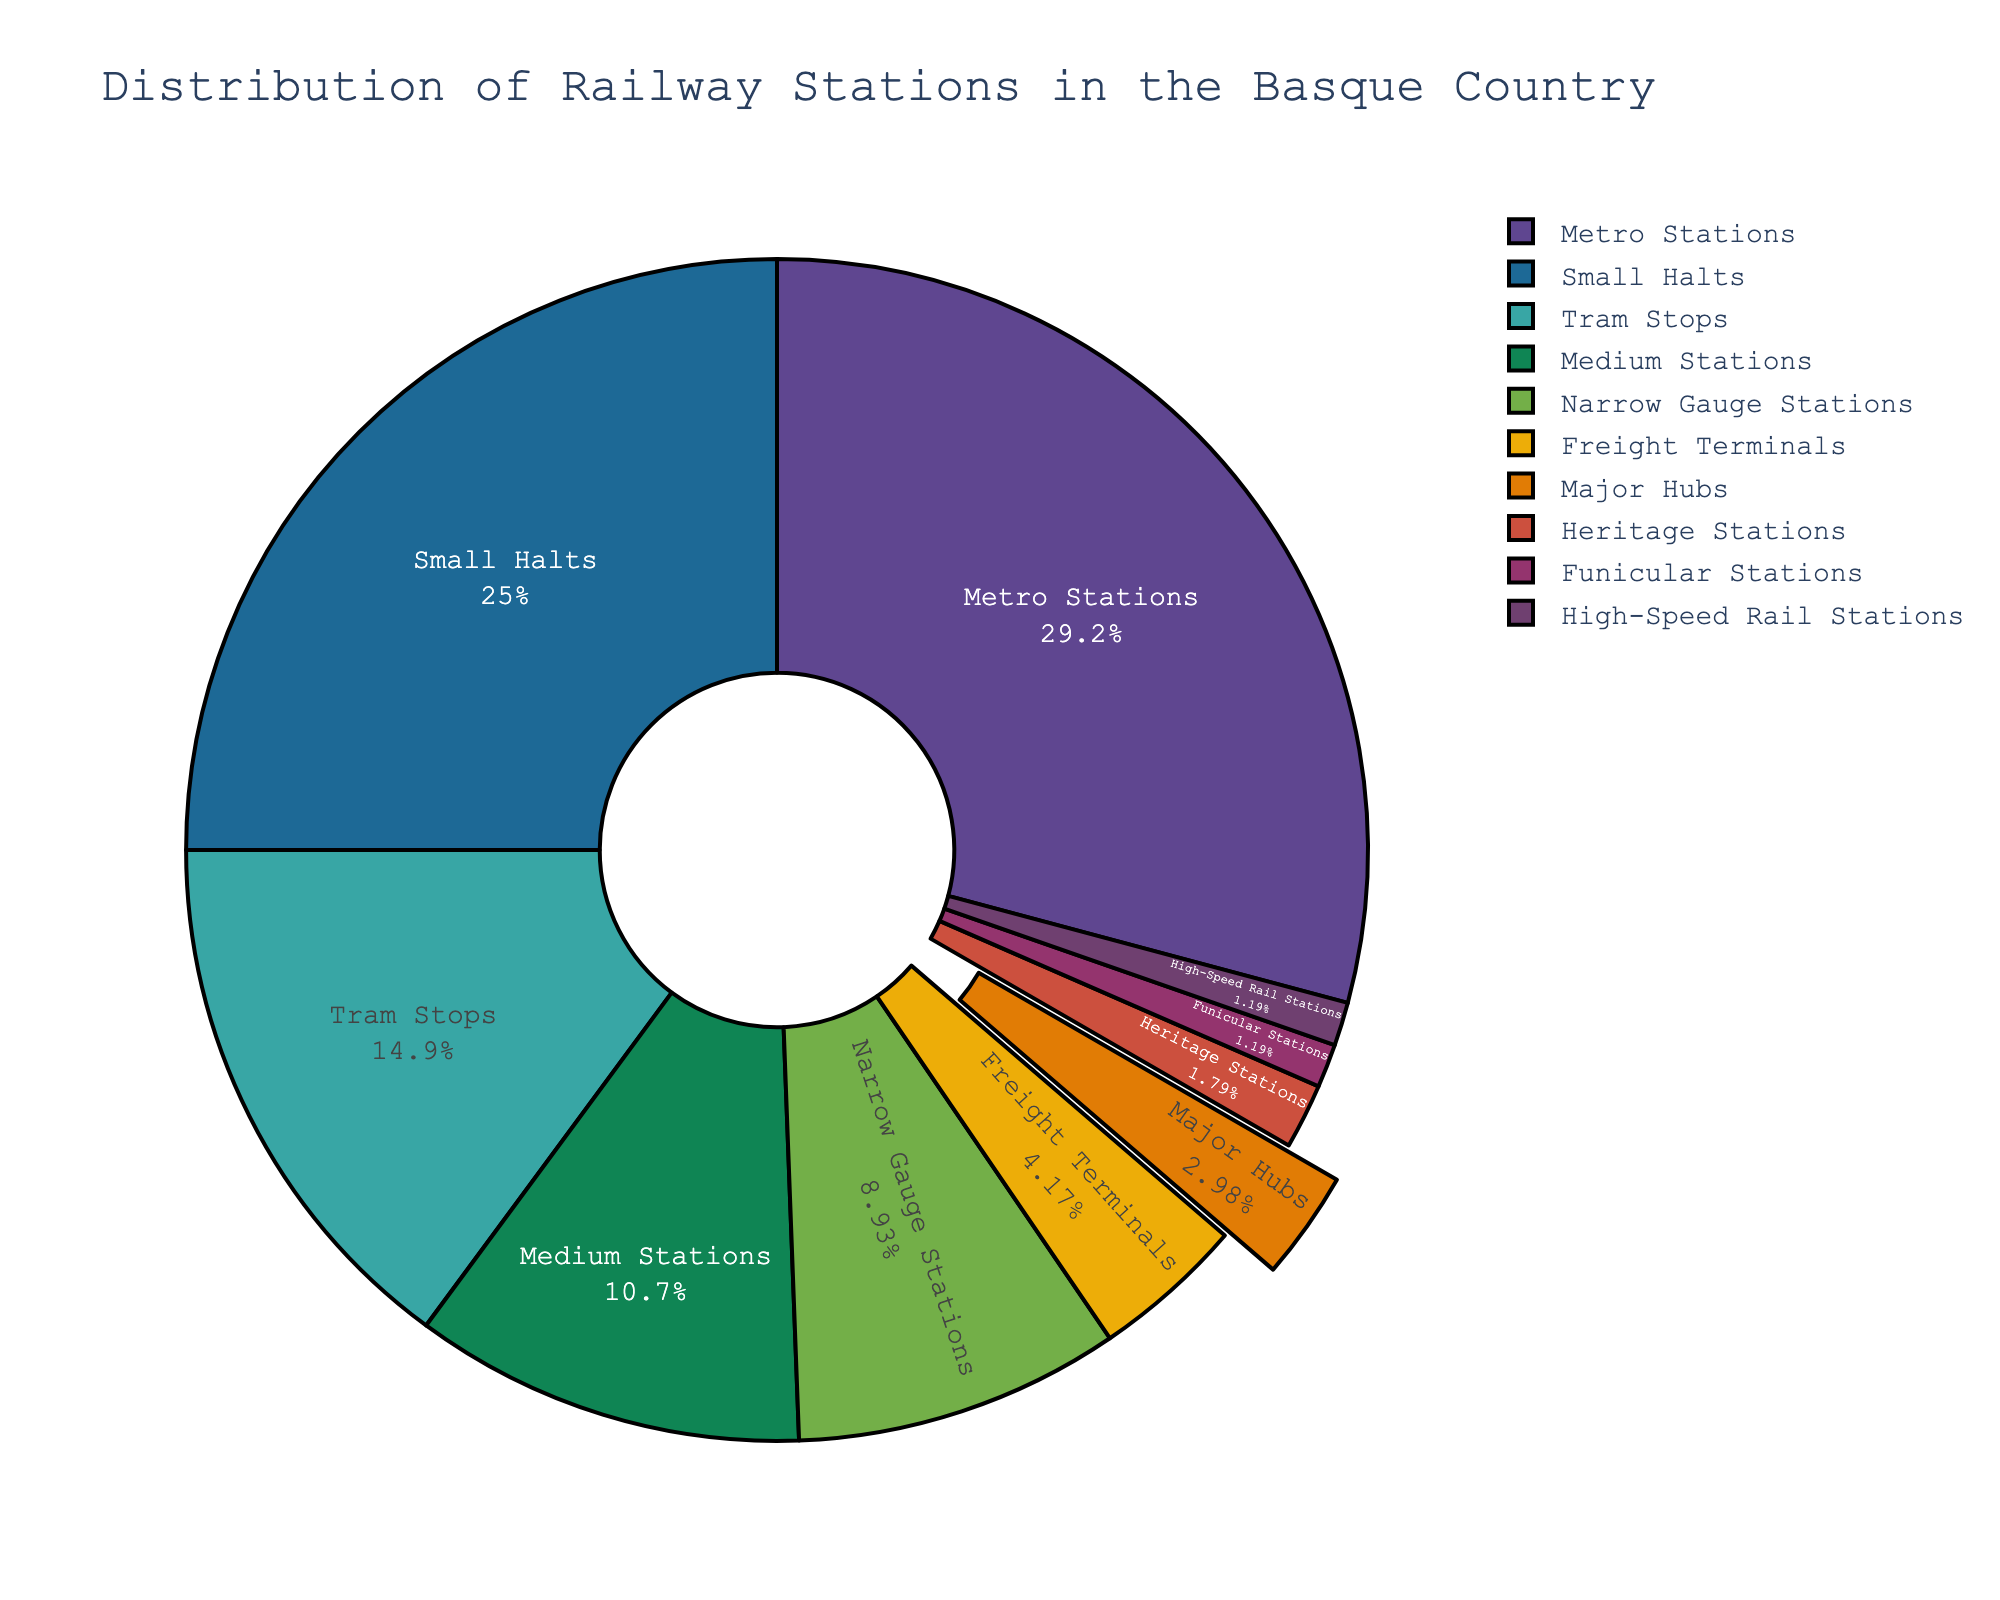Which type of station has the highest percentage in the distribution? By looking at the pie chart, we can see that metro stations occupy the largest portion of the pie chart, indicating they have the highest percentage.
Answer: Metro Stations How many more small halts are there than major hubs? From the data, there are 42 small halts and 5 major hubs. Subtract the number of major hubs from the number of small halts, which is 42 - 5.
Answer: 37 What is the combined percentage of high-speed rail stations and funicular stations? Identify the segments for high-speed rail and funicular stations and add their percentages together from the pie chart. Each has small, equal segments indicating the sizes are very similar.
Answer: ~4% (assuming each approximately 2%) Compare the number of medium stations and narrow gauge stations. Which is greater, and by how much? The pie chart shows there are 18 medium stations and 15 narrow gauge stations. Subtract the number of narrow gauge stations from medium stations to find the difference.
Answer: Medium stations by 3 What is the percentage of metro stations relative to the total number of stations? First, sum the total number of stations from all categories, which is 168. Divide the number of metro stations (49) by the total to find the percentage: (49 / 168) * 100.
Answer: ~29.2% Which types of stations together make up more than half of the total stations? Sum the percentages of the top types from the pie chart until you exceed 50%. Metro stations, small halts, and tram stops together exceed half the total stations.
Answer: Metro Stations, Small Halts, Tram Stops What fraction of the total stations are major hubs? Divide the number of major hubs (5) by the total number of stations (168) to form a fraction.
Answer: 5/168 or simplified approximately 1/34 If you combine freight terminals and heritage stations, what is their combined share among the total number of stations? Add the number of freight terminals and heritage stations: 7 + 3 = 10. Then, divide by the total number (168) to find the combined share percentage: (10 / 168) * 100.
Answer: ~5.95% Which type of station has the least representation on the pie chart? By looking at the pie chart, identify the smallest segment. Both high-speed rail stations and funicular stations appear to have the smallest percentages.
Answer: High-Speed Rail Stations and Funicular Stations Estimate the percentage difference between tram stops and narrow gauge stations. Identify the segments for tram stops and narrow gauge stations and estimate their percentages, then calculate the difference between them (approximate tram stops 14.9%, narrow gauge 8.9%).
Answer: ~6% 